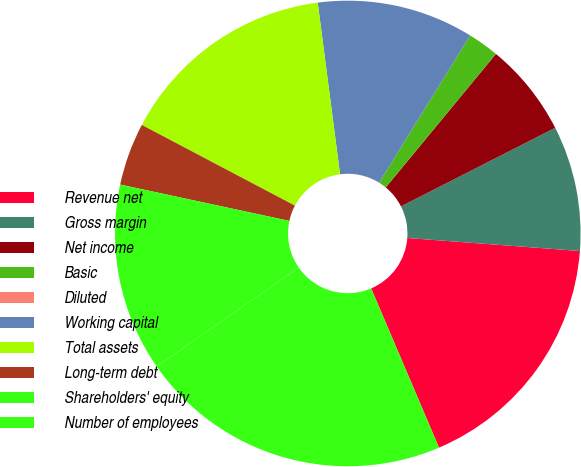Convert chart. <chart><loc_0><loc_0><loc_500><loc_500><pie_chart><fcel>Revenue net<fcel>Gross margin<fcel>Net income<fcel>Basic<fcel>Diluted<fcel>Working capital<fcel>Total assets<fcel>Long-term debt<fcel>Shareholders' equity<fcel>Number of employees<nl><fcel>17.39%<fcel>8.7%<fcel>6.52%<fcel>2.17%<fcel>0.0%<fcel>10.87%<fcel>15.22%<fcel>4.35%<fcel>13.04%<fcel>21.74%<nl></chart> 